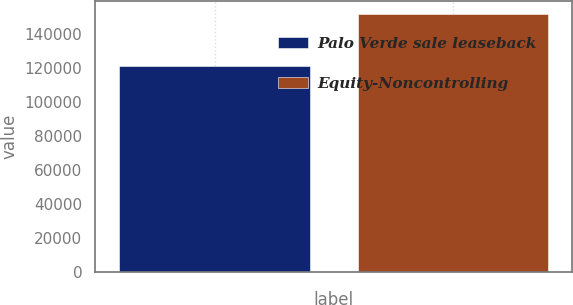Convert chart to OTSL. <chart><loc_0><loc_0><loc_500><loc_500><bar_chart><fcel>Palo Verde sale leaseback<fcel>Equity-Noncontrolling<nl><fcel>121255<fcel>151609<nl></chart> 